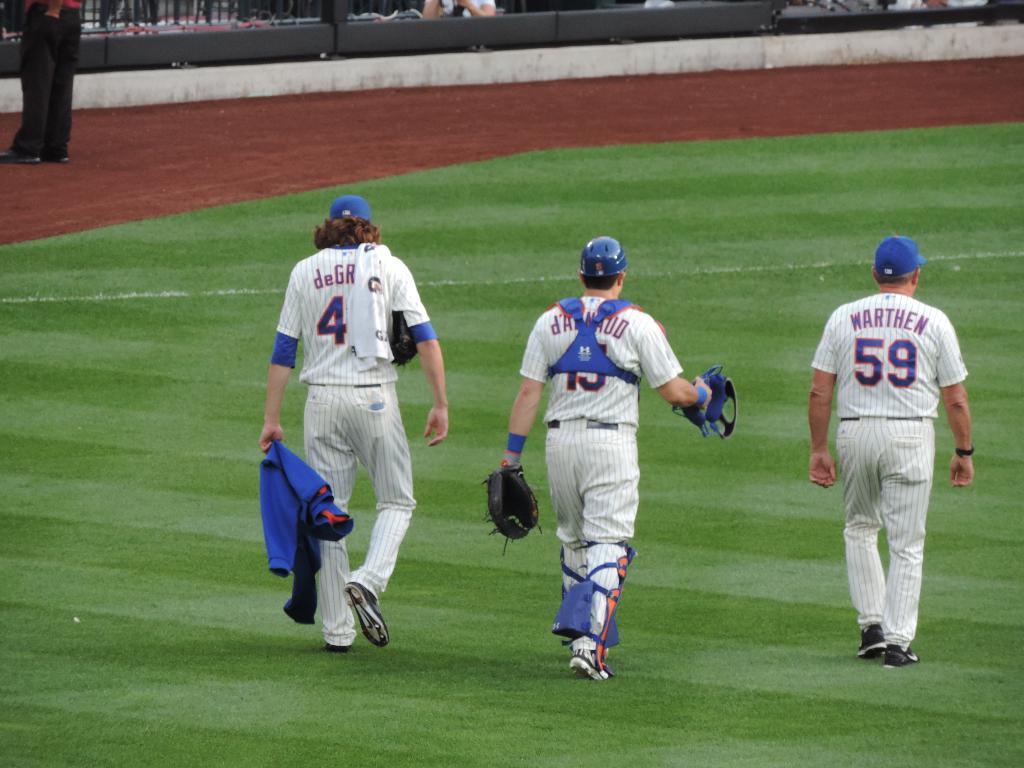What number is the man holding the jacket?
Your answer should be very brief. 4. 